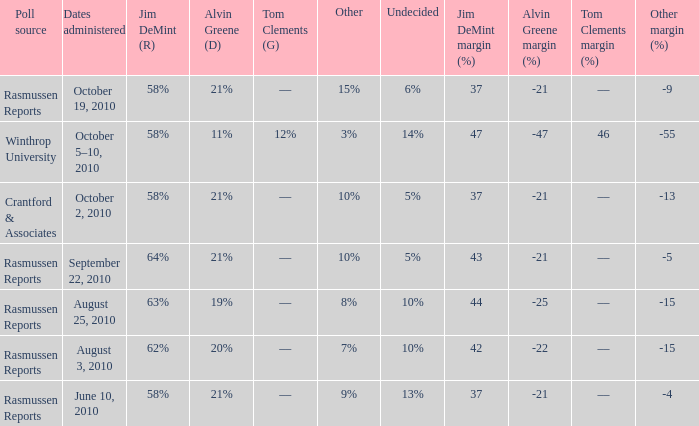What was the vote for Alvin Green when other was 9%? 21%. 